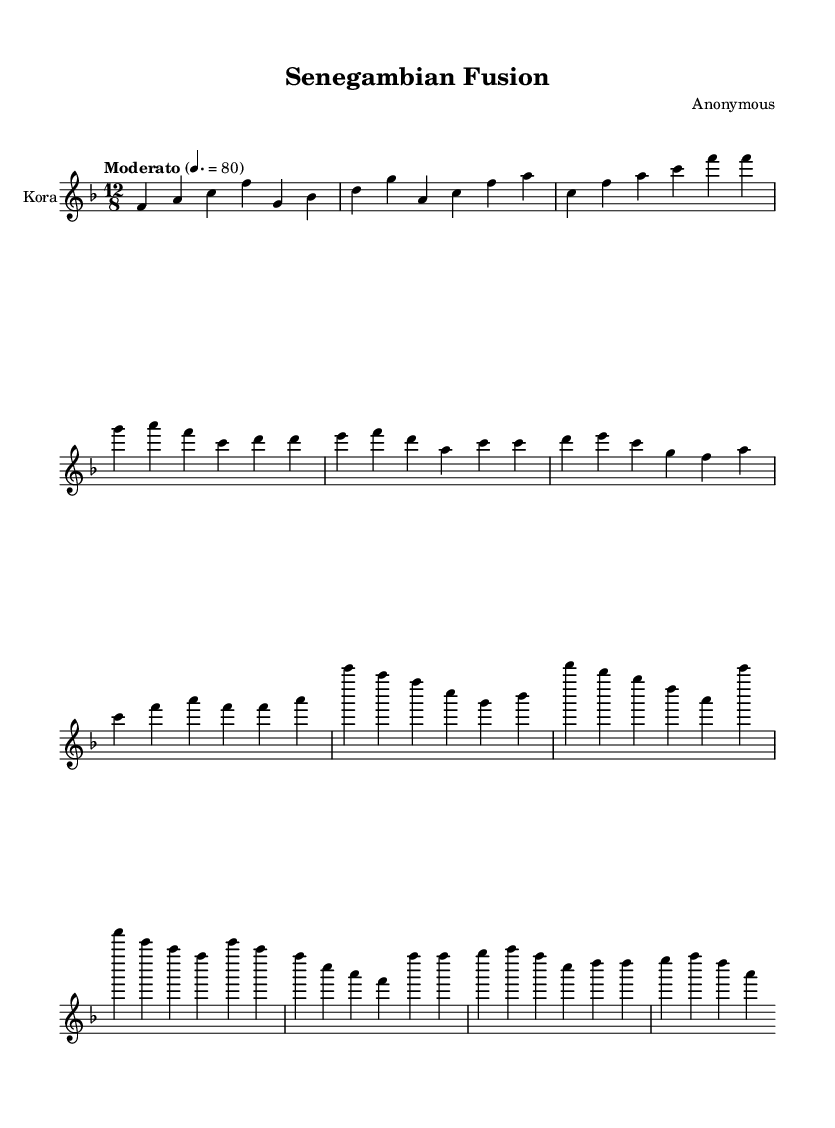What is the key signature of this music? The key signature is F major, which has one flat (B♭) as indicated by the key signature at the beginning of the staff.
Answer: F major What is the time signature of this music? The time signature is 12/8, which is shown just after the key signature. This indicates a compound time signature where there are 12 eighth notes per measure.
Answer: 12/8 What is the tempo marking of this composition? The tempo marking reads "Moderato" with a metronome marking of 80 beats per minute. This provides the performance speed for the piece.
Answer: Moderato 4. = 80 How many measures are in the introduction? The introduction consists of four measures, counted as individual units between the bars before the next section begins.
Answer: 4 Which section comes after the introduction? The section that follows the introduction is the verse, as indicated by the structure of the composition.
Answer: Verse Which instrument is indicated for this score? The instrument indicated in the score is the Kora, denoted by the instrument name at the beginning of the staff.
Answer: Kora What compositional style is this music reflecting? This music reflects a fusion style, integrating traditional Senegambian elements with modern techniques, as suggested by the title "Senegambian Fusion".
Answer: Fusion 